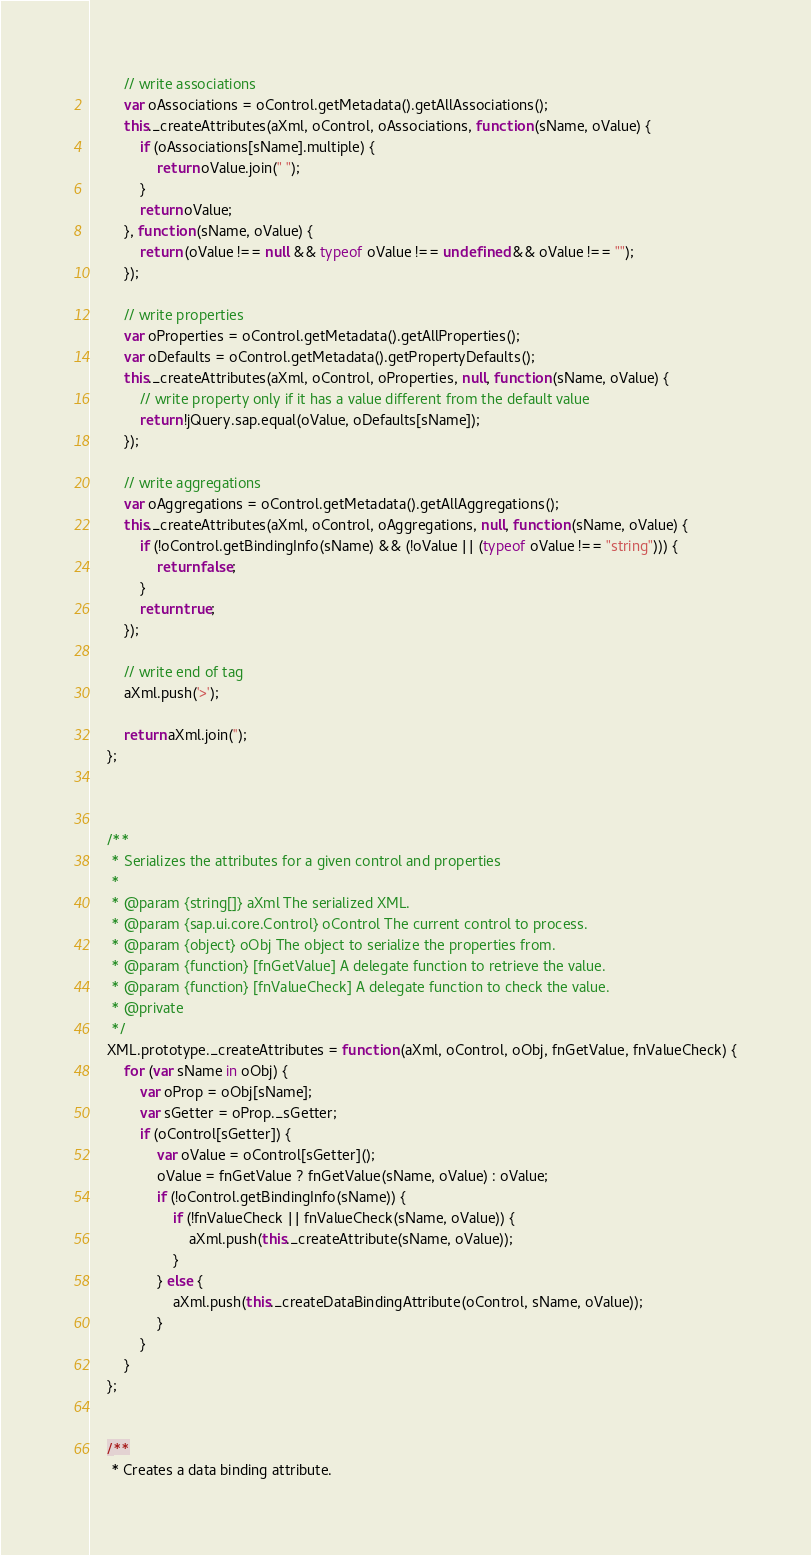Convert code to text. <code><loc_0><loc_0><loc_500><loc_500><_JavaScript_>		// write associations
		var oAssociations = oControl.getMetadata().getAllAssociations();
		this._createAttributes(aXml, oControl, oAssociations, function (sName, oValue) {
			if (oAssociations[sName].multiple) {
				return oValue.join(" ");
			}
			return oValue;
		}, function (sName, oValue) {
			return (oValue !== null && typeof oValue !== undefined && oValue !== "");
		});

		// write properties
		var oProperties = oControl.getMetadata().getAllProperties();
		var oDefaults = oControl.getMetadata().getPropertyDefaults();
		this._createAttributes(aXml, oControl, oProperties, null, function (sName, oValue) {
			// write property only if it has a value different from the default value
			return !jQuery.sap.equal(oValue, oDefaults[sName]);
		});

		// write aggregations
		var oAggregations = oControl.getMetadata().getAllAggregations();
		this._createAttributes(aXml, oControl, oAggregations, null, function (sName, oValue) {
			if (!oControl.getBindingInfo(sName) && (!oValue || (typeof oValue !== "string"))) {
				return false;
			}
			return true;
		});

		// write end of tag
		aXml.push('>');

		return aXml.join('');
	};



	/**
	 * Serializes the attributes for a given control and properties
	 *
	 * @param {string[]} aXml The serialized XML.
	 * @param {sap.ui.core.Control} oControl The current control to process.
	 * @param {object} oObj The object to serialize the properties from.
	 * @param {function} [fnGetValue] A delegate function to retrieve the value.
	 * @param {function} [fnValueCheck] A delegate function to check the value.
	 * @private
	 */
	XML.prototype._createAttributes = function (aXml, oControl, oObj, fnGetValue, fnValueCheck) {
		for (var sName in oObj) {
			var oProp = oObj[sName];
			var sGetter = oProp._sGetter;
			if (oControl[sGetter]) {
				var oValue = oControl[sGetter]();
				oValue = fnGetValue ? fnGetValue(sName, oValue) : oValue;
				if (!oControl.getBindingInfo(sName)) {
					if (!fnValueCheck || fnValueCheck(sName, oValue)) {
						aXml.push(this._createAttribute(sName, oValue));
					}
				} else {
					aXml.push(this._createDataBindingAttribute(oControl, sName, oValue));
				}
			}
		}
	};


	/**
	 * Creates a data binding attribute.</code> 